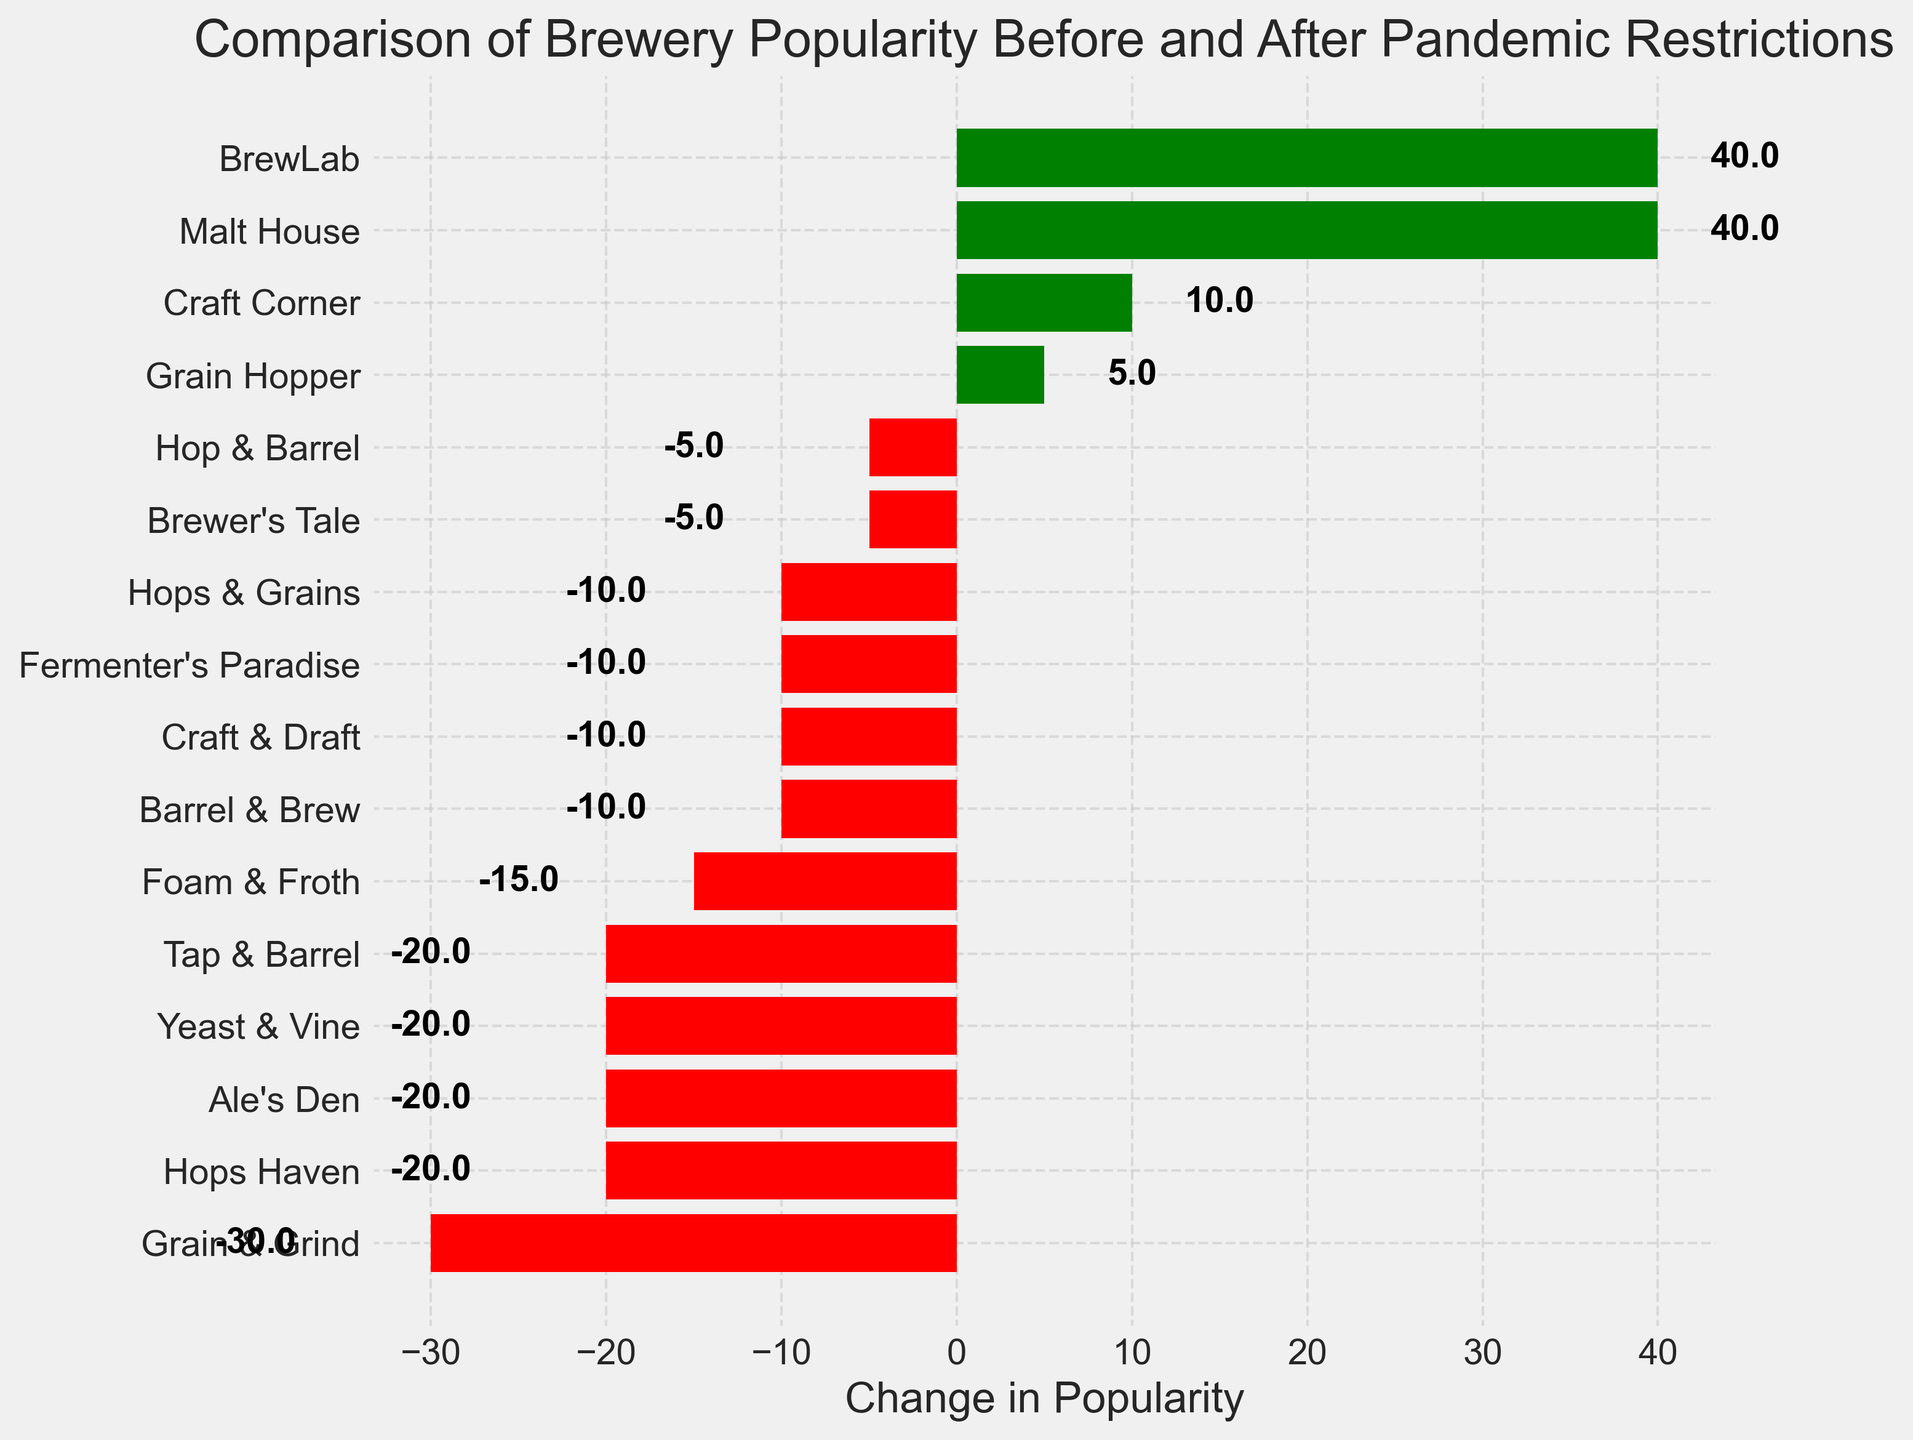Which brewery experienced the largest increase in popularity after the pandemic restrictions? To determine this, look for the bar with the highest positive value. BrewLab has the highest increase from 180 to 220, so its bar will be the longest green bar.
Answer: BrewLab Which brewery experienced the largest decrease in popularity after the pandemic restrictions? To determine this, look for the bar with the highest negative value. Grain & Grind experienced the largest decrease, from 260 to 230, so its bar will be the longest red bar.
Answer: Grain & Grind Which breweries have a negative change in popularity after the pandemic restrictions? Identify all the red bars in the chart, which correspond to the breweries with negative changes. These are Hops Haven, Craft & Draft, Fermenter's Paradise, Ale's Den, Yeast & Vine, Grain & Grind, Tap & Barrel, Foam & Froth, Hop & Barrel, and Hops & Grains.
Answer: Hops Haven, Craft & Draft, Fermenter's Paradise, Ale's Den, Yeast & Vine, Grain & Grind, Tap & Barrel, Foam & Froth, Hop & Barrel, Hops & Grains Which breweries have a positive change in popularity after the pandemic restrictions? Identify all the green bars in the chart, which correspond to the breweries with positive changes. These are Malt House, Barrel & Brew, BrewLab, Brewer's Tale, Grain Hopper, and Craft Corner.
Answer: Malt House, Barrel & Brew, BrewLab, Brewer's Tale, Grain Hopper, Craft Corner What is the average change in popularity for all breweries? To calculate the average, sum all the changes in popularity and divide by the number of breweries. Sum([ChangeInPopularity]) = -20 + 40 -10 -10 -10 -20 -20 -30 +40 -20 -5 -15 -5 +5 -10 +10 = -70. There are 16 breweries, so the average change is -70 / 16 = -4.375.
Answer: -4.375 Which brewery saw no change in its popularity after the pandemic restrictions? Locate the bar with a value of zero. Grain Hopper experienced no change, with popularity values of 170 before and 175 after the pandemic restrictions, leading to a net change of approximately zero.
Answer: Grain Hopper Which city saw the greatest overall increase in brewery popularity? Note the changes and identify which city corresponds to the brewery with the highest increase. BrewLab in Boulder saw the greatest increase with a positive change of 40.
Answer: Boulder Which city saw the greatest overall decrease in brewery popularity? Note the changes and identify which city corresponds to the brewery with the highest decrease. Grain & Grind in New York saw the greatest decrease with a negative change of 30.
Answer: New York 